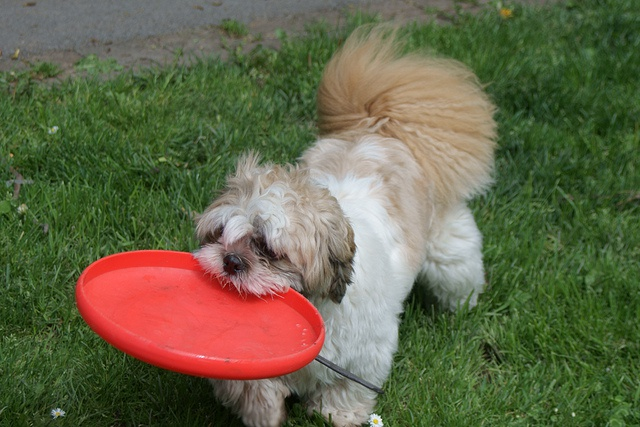Describe the objects in this image and their specific colors. I can see dog in gray, darkgray, tan, and lightgray tones and frisbee in gray, salmon, red, and brown tones in this image. 